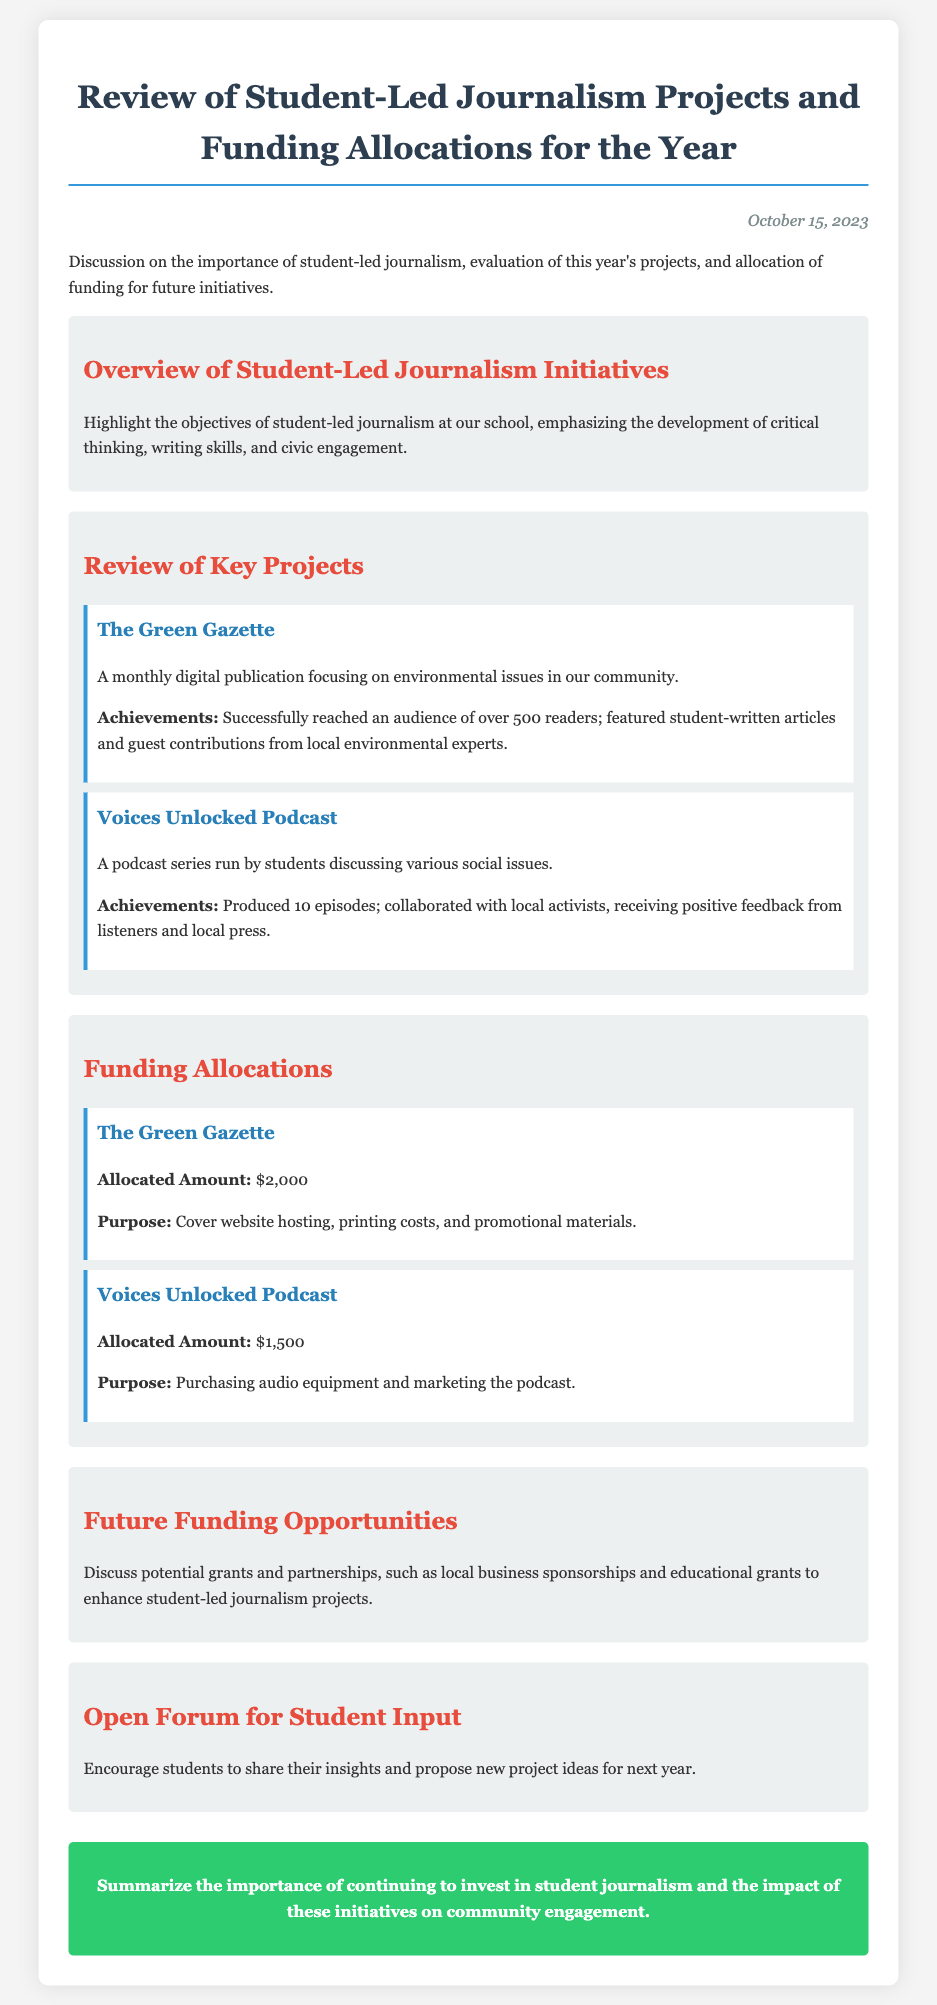What is the date of the review? The date mentioned in the document header indicates when the review took place.
Answer: October 15, 2023 What is the name of the first key project? The first project listed under the review of key projects is highlighted with its title.
Answer: The Green Gazette How many episodes did the Voices Unlocked Podcast produce? The number of episodes produced is explicitly mentioned alongside the project's achievements.
Answer: 10 episodes What was the allocated amount for The Green Gazette? The funding allocation for each project includes a specific amount, listed in the document.
Answer: $2,000 What is the purpose of the funding allocated to Voices Unlocked Podcast? The document specifies the purpose of the funding allocation for each project.
Answer: Purchasing audio equipment and marketing the podcast What is a potential future funding opportunity mentioned? The section on future funding opportunities discusses different approaches to funding.
Answer: Local business sponsorships What is the main objective of student-led journalism at the school? The overview section outlines the key aims of the student-led journalism initiatives.
Answer: Development of critical thinking, writing skills, and civic engagement What kind of input is encouraged from students? The document specifies the open forum section focusing on student engagement and suggestions.
Answer: New project ideas for next year 